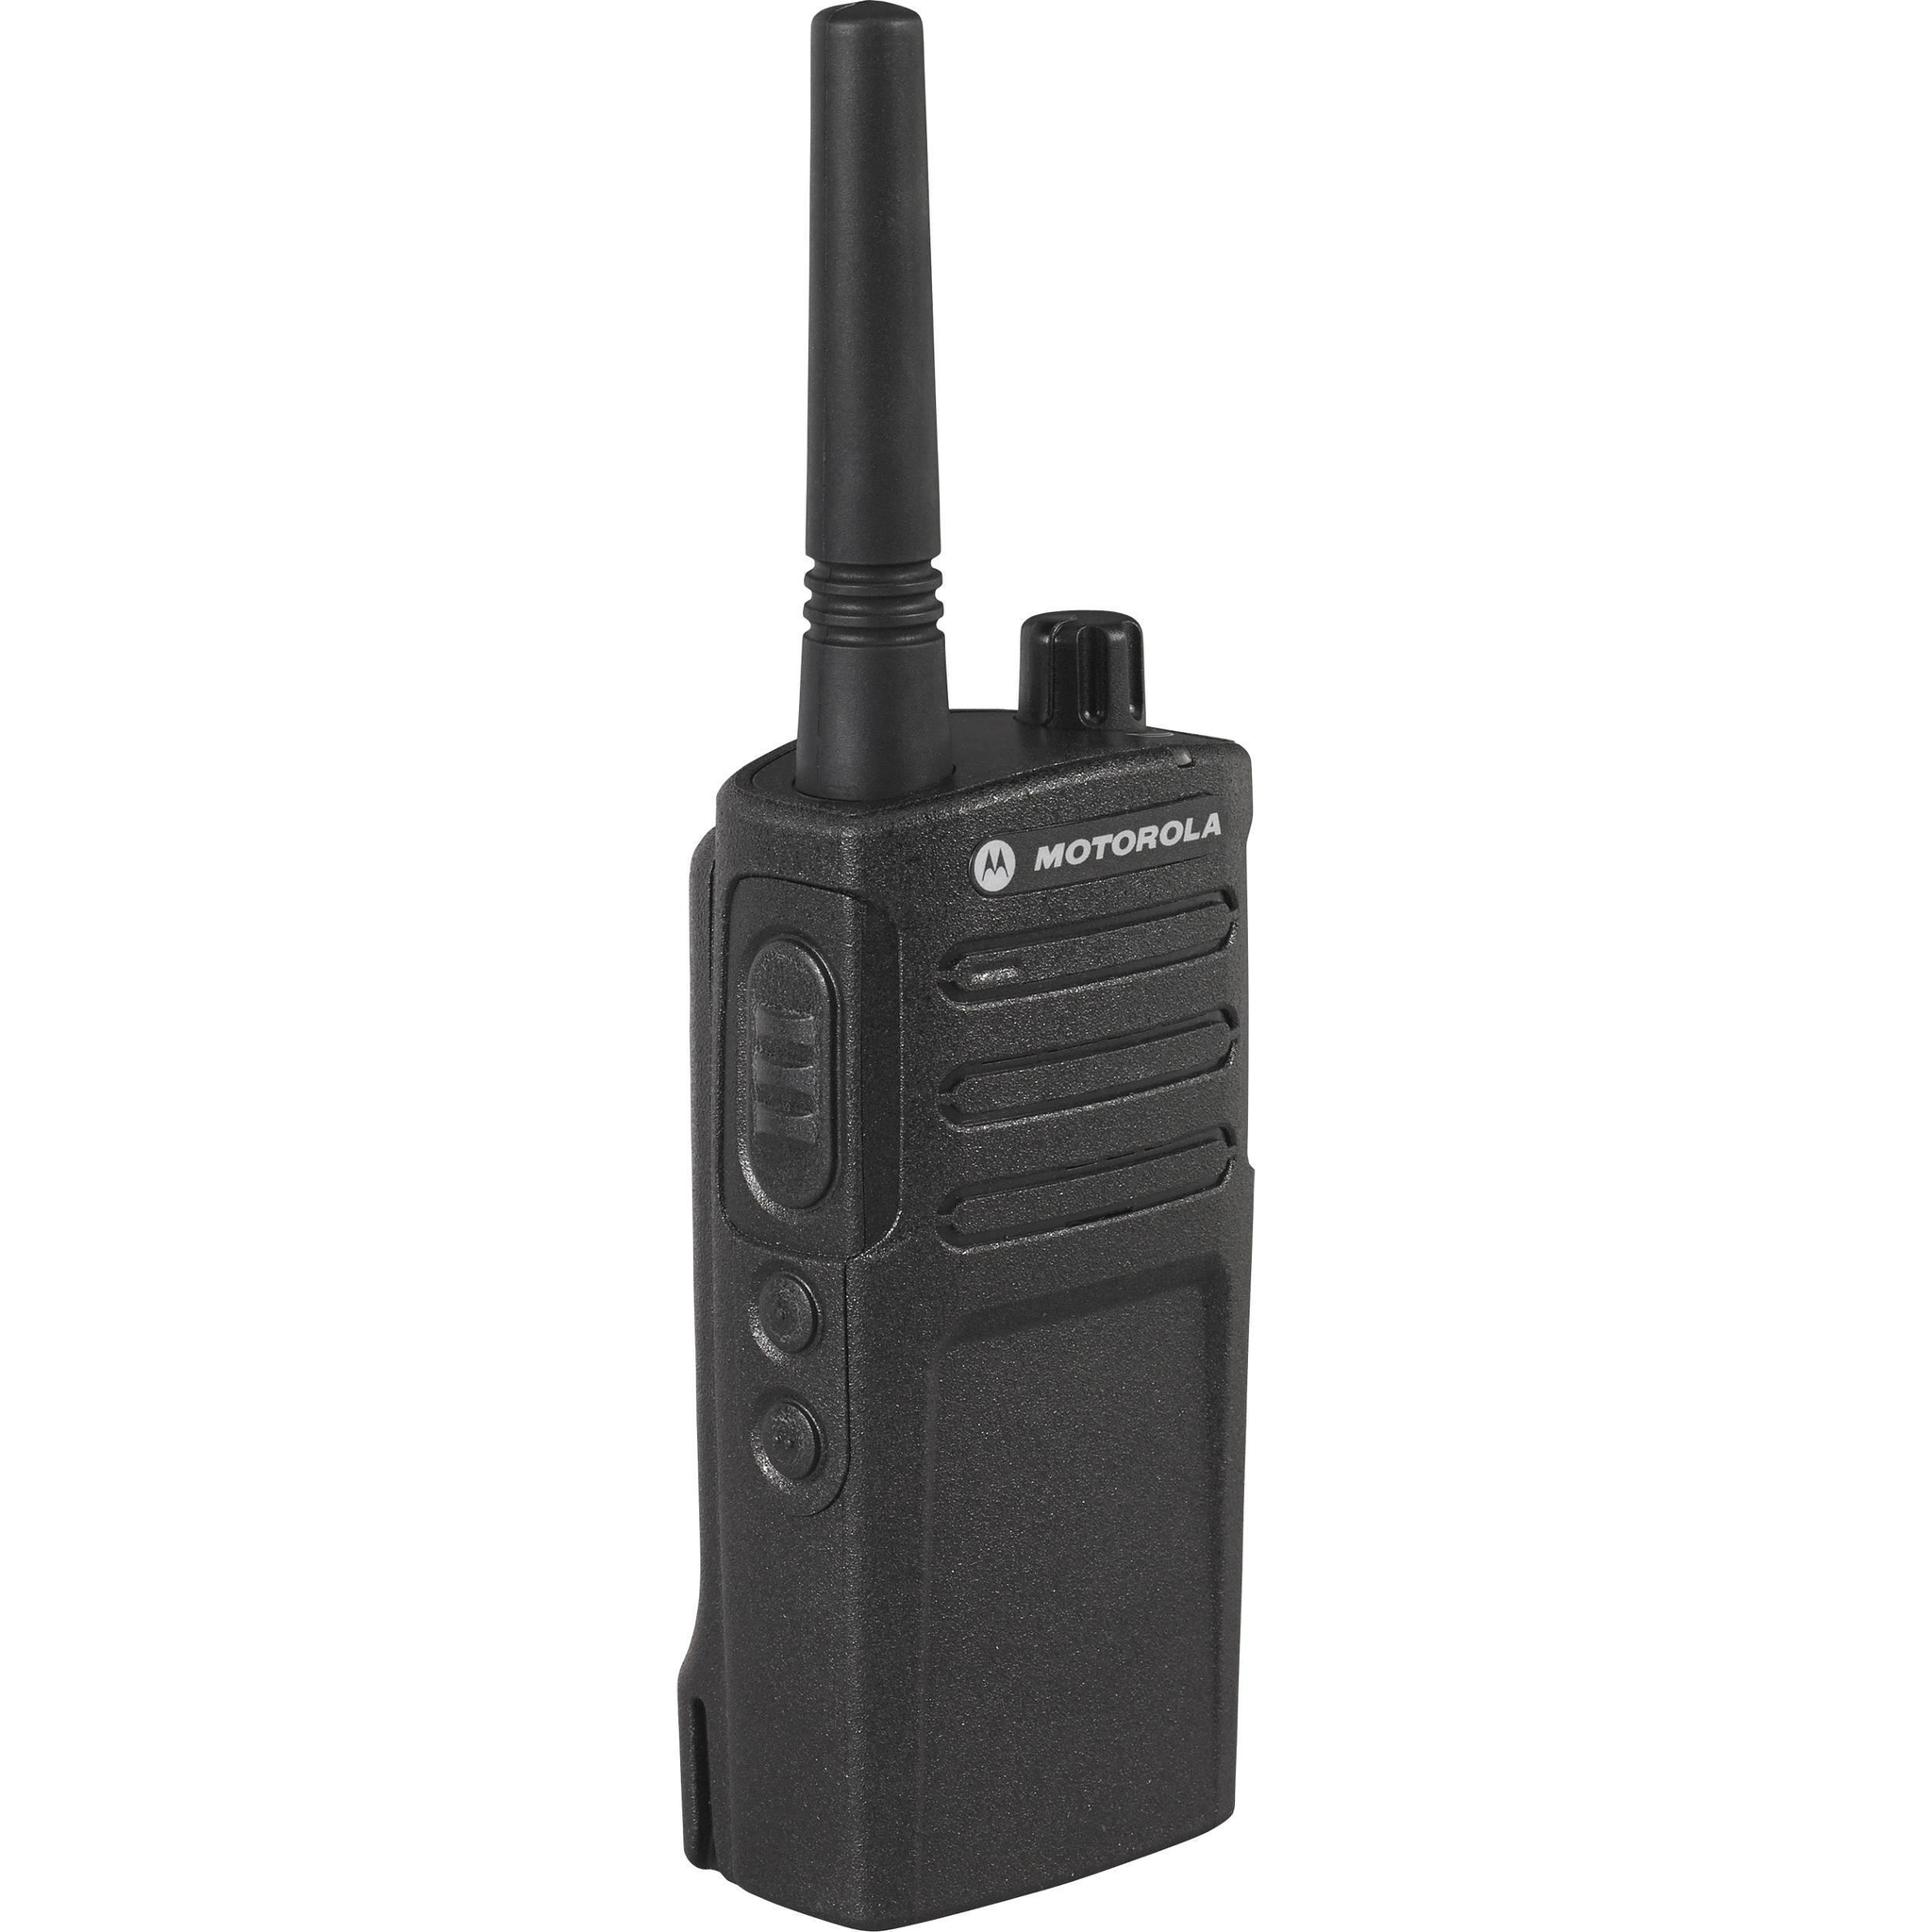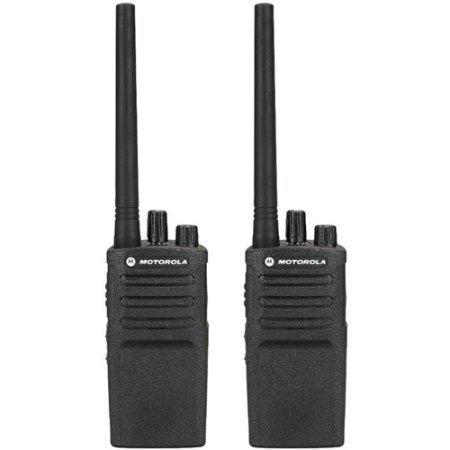The first image is the image on the left, the second image is the image on the right. For the images displayed, is the sentence "There are three walkie talkies." factually correct? Answer yes or no. Yes. The first image is the image on the left, the second image is the image on the right. Analyze the images presented: Is the assertion "At least 3 walkie-talkies are lined up next to each other in each picture." valid? Answer yes or no. No. 